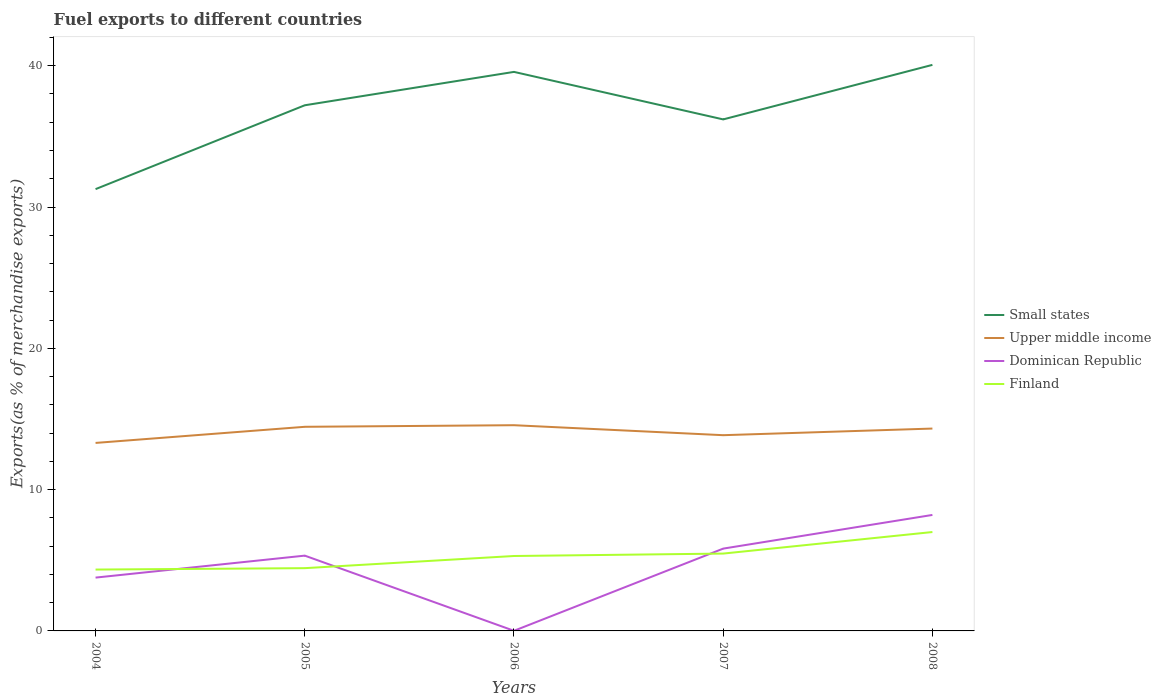Does the line corresponding to Dominican Republic intersect with the line corresponding to Upper middle income?
Your response must be concise. No. Is the number of lines equal to the number of legend labels?
Give a very brief answer. Yes. Across all years, what is the maximum percentage of exports to different countries in Upper middle income?
Keep it short and to the point. 13.31. What is the total percentage of exports to different countries in Upper middle income in the graph?
Keep it short and to the point. -0.11. What is the difference between the highest and the second highest percentage of exports to different countries in Upper middle income?
Make the answer very short. 1.25. How many lines are there?
Your answer should be compact. 4. Does the graph contain any zero values?
Your answer should be compact. No. Where does the legend appear in the graph?
Provide a succinct answer. Center right. How are the legend labels stacked?
Offer a terse response. Vertical. What is the title of the graph?
Provide a short and direct response. Fuel exports to different countries. Does "St. Lucia" appear as one of the legend labels in the graph?
Provide a short and direct response. No. What is the label or title of the Y-axis?
Provide a short and direct response. Exports(as % of merchandise exports). What is the Exports(as % of merchandise exports) of Small states in 2004?
Give a very brief answer. 31.27. What is the Exports(as % of merchandise exports) of Upper middle income in 2004?
Provide a succinct answer. 13.31. What is the Exports(as % of merchandise exports) in Dominican Republic in 2004?
Provide a succinct answer. 3.77. What is the Exports(as % of merchandise exports) in Finland in 2004?
Provide a succinct answer. 4.34. What is the Exports(as % of merchandise exports) in Small states in 2005?
Keep it short and to the point. 37.2. What is the Exports(as % of merchandise exports) of Upper middle income in 2005?
Provide a succinct answer. 14.45. What is the Exports(as % of merchandise exports) of Dominican Republic in 2005?
Ensure brevity in your answer.  5.33. What is the Exports(as % of merchandise exports) in Finland in 2005?
Provide a succinct answer. 4.44. What is the Exports(as % of merchandise exports) in Small states in 2006?
Offer a terse response. 39.56. What is the Exports(as % of merchandise exports) of Upper middle income in 2006?
Provide a short and direct response. 14.56. What is the Exports(as % of merchandise exports) in Dominican Republic in 2006?
Your answer should be compact. 0.01. What is the Exports(as % of merchandise exports) in Finland in 2006?
Give a very brief answer. 5.3. What is the Exports(as % of merchandise exports) in Small states in 2007?
Provide a succinct answer. 36.2. What is the Exports(as % of merchandise exports) of Upper middle income in 2007?
Provide a short and direct response. 13.85. What is the Exports(as % of merchandise exports) in Dominican Republic in 2007?
Provide a succinct answer. 5.83. What is the Exports(as % of merchandise exports) of Finland in 2007?
Offer a terse response. 5.47. What is the Exports(as % of merchandise exports) of Small states in 2008?
Ensure brevity in your answer.  40.06. What is the Exports(as % of merchandise exports) of Upper middle income in 2008?
Provide a short and direct response. 14.32. What is the Exports(as % of merchandise exports) of Dominican Republic in 2008?
Your response must be concise. 8.21. What is the Exports(as % of merchandise exports) in Finland in 2008?
Ensure brevity in your answer.  7. Across all years, what is the maximum Exports(as % of merchandise exports) of Small states?
Provide a succinct answer. 40.06. Across all years, what is the maximum Exports(as % of merchandise exports) of Upper middle income?
Your answer should be compact. 14.56. Across all years, what is the maximum Exports(as % of merchandise exports) in Dominican Republic?
Your response must be concise. 8.21. Across all years, what is the maximum Exports(as % of merchandise exports) of Finland?
Provide a succinct answer. 7. Across all years, what is the minimum Exports(as % of merchandise exports) of Small states?
Keep it short and to the point. 31.27. Across all years, what is the minimum Exports(as % of merchandise exports) in Upper middle income?
Your response must be concise. 13.31. Across all years, what is the minimum Exports(as % of merchandise exports) in Dominican Republic?
Keep it short and to the point. 0.01. Across all years, what is the minimum Exports(as % of merchandise exports) in Finland?
Ensure brevity in your answer.  4.34. What is the total Exports(as % of merchandise exports) in Small states in the graph?
Make the answer very short. 184.29. What is the total Exports(as % of merchandise exports) of Upper middle income in the graph?
Offer a terse response. 70.48. What is the total Exports(as % of merchandise exports) of Dominican Republic in the graph?
Your response must be concise. 23.14. What is the total Exports(as % of merchandise exports) in Finland in the graph?
Provide a short and direct response. 26.56. What is the difference between the Exports(as % of merchandise exports) of Small states in 2004 and that in 2005?
Make the answer very short. -5.93. What is the difference between the Exports(as % of merchandise exports) of Upper middle income in 2004 and that in 2005?
Provide a succinct answer. -1.14. What is the difference between the Exports(as % of merchandise exports) in Dominican Republic in 2004 and that in 2005?
Your answer should be compact. -1.55. What is the difference between the Exports(as % of merchandise exports) in Finland in 2004 and that in 2005?
Offer a very short reply. -0.1. What is the difference between the Exports(as % of merchandise exports) of Small states in 2004 and that in 2006?
Offer a very short reply. -8.3. What is the difference between the Exports(as % of merchandise exports) in Upper middle income in 2004 and that in 2006?
Offer a very short reply. -1.25. What is the difference between the Exports(as % of merchandise exports) of Dominican Republic in 2004 and that in 2006?
Make the answer very short. 3.76. What is the difference between the Exports(as % of merchandise exports) of Finland in 2004 and that in 2006?
Ensure brevity in your answer.  -0.96. What is the difference between the Exports(as % of merchandise exports) in Small states in 2004 and that in 2007?
Keep it short and to the point. -4.93. What is the difference between the Exports(as % of merchandise exports) of Upper middle income in 2004 and that in 2007?
Offer a very short reply. -0.55. What is the difference between the Exports(as % of merchandise exports) of Dominican Republic in 2004 and that in 2007?
Provide a short and direct response. -2.05. What is the difference between the Exports(as % of merchandise exports) of Finland in 2004 and that in 2007?
Provide a short and direct response. -1.13. What is the difference between the Exports(as % of merchandise exports) in Small states in 2004 and that in 2008?
Your response must be concise. -8.79. What is the difference between the Exports(as % of merchandise exports) of Upper middle income in 2004 and that in 2008?
Offer a very short reply. -1.02. What is the difference between the Exports(as % of merchandise exports) in Dominican Republic in 2004 and that in 2008?
Provide a short and direct response. -4.44. What is the difference between the Exports(as % of merchandise exports) of Finland in 2004 and that in 2008?
Your response must be concise. -2.66. What is the difference between the Exports(as % of merchandise exports) of Small states in 2005 and that in 2006?
Provide a succinct answer. -2.36. What is the difference between the Exports(as % of merchandise exports) of Upper middle income in 2005 and that in 2006?
Keep it short and to the point. -0.11. What is the difference between the Exports(as % of merchandise exports) in Dominican Republic in 2005 and that in 2006?
Provide a succinct answer. 5.32. What is the difference between the Exports(as % of merchandise exports) in Finland in 2005 and that in 2006?
Your response must be concise. -0.86. What is the difference between the Exports(as % of merchandise exports) of Small states in 2005 and that in 2007?
Your response must be concise. 1. What is the difference between the Exports(as % of merchandise exports) of Upper middle income in 2005 and that in 2007?
Your response must be concise. 0.59. What is the difference between the Exports(as % of merchandise exports) of Dominican Republic in 2005 and that in 2007?
Offer a very short reply. -0.5. What is the difference between the Exports(as % of merchandise exports) of Finland in 2005 and that in 2007?
Your answer should be very brief. -1.03. What is the difference between the Exports(as % of merchandise exports) of Small states in 2005 and that in 2008?
Provide a succinct answer. -2.86. What is the difference between the Exports(as % of merchandise exports) of Upper middle income in 2005 and that in 2008?
Offer a terse response. 0.12. What is the difference between the Exports(as % of merchandise exports) of Dominican Republic in 2005 and that in 2008?
Your answer should be very brief. -2.88. What is the difference between the Exports(as % of merchandise exports) of Finland in 2005 and that in 2008?
Keep it short and to the point. -2.56. What is the difference between the Exports(as % of merchandise exports) in Small states in 2006 and that in 2007?
Make the answer very short. 3.36. What is the difference between the Exports(as % of merchandise exports) of Upper middle income in 2006 and that in 2007?
Keep it short and to the point. 0.71. What is the difference between the Exports(as % of merchandise exports) of Dominican Republic in 2006 and that in 2007?
Your answer should be compact. -5.82. What is the difference between the Exports(as % of merchandise exports) of Finland in 2006 and that in 2007?
Make the answer very short. -0.17. What is the difference between the Exports(as % of merchandise exports) in Small states in 2006 and that in 2008?
Make the answer very short. -0.5. What is the difference between the Exports(as % of merchandise exports) of Upper middle income in 2006 and that in 2008?
Ensure brevity in your answer.  0.24. What is the difference between the Exports(as % of merchandise exports) in Dominican Republic in 2006 and that in 2008?
Offer a very short reply. -8.2. What is the difference between the Exports(as % of merchandise exports) in Finland in 2006 and that in 2008?
Ensure brevity in your answer.  -1.7. What is the difference between the Exports(as % of merchandise exports) of Small states in 2007 and that in 2008?
Your response must be concise. -3.86. What is the difference between the Exports(as % of merchandise exports) in Upper middle income in 2007 and that in 2008?
Your answer should be compact. -0.47. What is the difference between the Exports(as % of merchandise exports) in Dominican Republic in 2007 and that in 2008?
Keep it short and to the point. -2.38. What is the difference between the Exports(as % of merchandise exports) of Finland in 2007 and that in 2008?
Give a very brief answer. -1.53. What is the difference between the Exports(as % of merchandise exports) in Small states in 2004 and the Exports(as % of merchandise exports) in Upper middle income in 2005?
Your answer should be very brief. 16.82. What is the difference between the Exports(as % of merchandise exports) in Small states in 2004 and the Exports(as % of merchandise exports) in Dominican Republic in 2005?
Keep it short and to the point. 25.94. What is the difference between the Exports(as % of merchandise exports) of Small states in 2004 and the Exports(as % of merchandise exports) of Finland in 2005?
Offer a terse response. 26.82. What is the difference between the Exports(as % of merchandise exports) in Upper middle income in 2004 and the Exports(as % of merchandise exports) in Dominican Republic in 2005?
Give a very brief answer. 7.98. What is the difference between the Exports(as % of merchandise exports) in Upper middle income in 2004 and the Exports(as % of merchandise exports) in Finland in 2005?
Keep it short and to the point. 8.86. What is the difference between the Exports(as % of merchandise exports) in Dominican Republic in 2004 and the Exports(as % of merchandise exports) in Finland in 2005?
Your response must be concise. -0.67. What is the difference between the Exports(as % of merchandise exports) of Small states in 2004 and the Exports(as % of merchandise exports) of Upper middle income in 2006?
Make the answer very short. 16.71. What is the difference between the Exports(as % of merchandise exports) in Small states in 2004 and the Exports(as % of merchandise exports) in Dominican Republic in 2006?
Provide a short and direct response. 31.26. What is the difference between the Exports(as % of merchandise exports) of Small states in 2004 and the Exports(as % of merchandise exports) of Finland in 2006?
Make the answer very short. 25.96. What is the difference between the Exports(as % of merchandise exports) of Upper middle income in 2004 and the Exports(as % of merchandise exports) of Dominican Republic in 2006?
Keep it short and to the point. 13.3. What is the difference between the Exports(as % of merchandise exports) of Upper middle income in 2004 and the Exports(as % of merchandise exports) of Finland in 2006?
Provide a short and direct response. 8. What is the difference between the Exports(as % of merchandise exports) of Dominican Republic in 2004 and the Exports(as % of merchandise exports) of Finland in 2006?
Your answer should be compact. -1.53. What is the difference between the Exports(as % of merchandise exports) of Small states in 2004 and the Exports(as % of merchandise exports) of Upper middle income in 2007?
Make the answer very short. 17.41. What is the difference between the Exports(as % of merchandise exports) of Small states in 2004 and the Exports(as % of merchandise exports) of Dominican Republic in 2007?
Keep it short and to the point. 25.44. What is the difference between the Exports(as % of merchandise exports) of Small states in 2004 and the Exports(as % of merchandise exports) of Finland in 2007?
Offer a very short reply. 25.79. What is the difference between the Exports(as % of merchandise exports) in Upper middle income in 2004 and the Exports(as % of merchandise exports) in Dominican Republic in 2007?
Your response must be concise. 7.48. What is the difference between the Exports(as % of merchandise exports) in Upper middle income in 2004 and the Exports(as % of merchandise exports) in Finland in 2007?
Offer a terse response. 7.83. What is the difference between the Exports(as % of merchandise exports) of Dominican Republic in 2004 and the Exports(as % of merchandise exports) of Finland in 2007?
Provide a short and direct response. -1.7. What is the difference between the Exports(as % of merchandise exports) in Small states in 2004 and the Exports(as % of merchandise exports) in Upper middle income in 2008?
Make the answer very short. 16.94. What is the difference between the Exports(as % of merchandise exports) of Small states in 2004 and the Exports(as % of merchandise exports) of Dominican Republic in 2008?
Provide a succinct answer. 23.06. What is the difference between the Exports(as % of merchandise exports) in Small states in 2004 and the Exports(as % of merchandise exports) in Finland in 2008?
Keep it short and to the point. 24.27. What is the difference between the Exports(as % of merchandise exports) of Upper middle income in 2004 and the Exports(as % of merchandise exports) of Dominican Republic in 2008?
Ensure brevity in your answer.  5.1. What is the difference between the Exports(as % of merchandise exports) in Upper middle income in 2004 and the Exports(as % of merchandise exports) in Finland in 2008?
Your response must be concise. 6.31. What is the difference between the Exports(as % of merchandise exports) in Dominican Republic in 2004 and the Exports(as % of merchandise exports) in Finland in 2008?
Offer a very short reply. -3.23. What is the difference between the Exports(as % of merchandise exports) of Small states in 2005 and the Exports(as % of merchandise exports) of Upper middle income in 2006?
Provide a short and direct response. 22.64. What is the difference between the Exports(as % of merchandise exports) in Small states in 2005 and the Exports(as % of merchandise exports) in Dominican Republic in 2006?
Provide a short and direct response. 37.19. What is the difference between the Exports(as % of merchandise exports) in Small states in 2005 and the Exports(as % of merchandise exports) in Finland in 2006?
Give a very brief answer. 31.9. What is the difference between the Exports(as % of merchandise exports) in Upper middle income in 2005 and the Exports(as % of merchandise exports) in Dominican Republic in 2006?
Ensure brevity in your answer.  14.44. What is the difference between the Exports(as % of merchandise exports) of Upper middle income in 2005 and the Exports(as % of merchandise exports) of Finland in 2006?
Keep it short and to the point. 9.14. What is the difference between the Exports(as % of merchandise exports) in Dominican Republic in 2005 and the Exports(as % of merchandise exports) in Finland in 2006?
Your answer should be compact. 0.03. What is the difference between the Exports(as % of merchandise exports) of Small states in 2005 and the Exports(as % of merchandise exports) of Upper middle income in 2007?
Give a very brief answer. 23.35. What is the difference between the Exports(as % of merchandise exports) in Small states in 2005 and the Exports(as % of merchandise exports) in Dominican Republic in 2007?
Ensure brevity in your answer.  31.38. What is the difference between the Exports(as % of merchandise exports) in Small states in 2005 and the Exports(as % of merchandise exports) in Finland in 2007?
Provide a short and direct response. 31.73. What is the difference between the Exports(as % of merchandise exports) in Upper middle income in 2005 and the Exports(as % of merchandise exports) in Dominican Republic in 2007?
Keep it short and to the point. 8.62. What is the difference between the Exports(as % of merchandise exports) of Upper middle income in 2005 and the Exports(as % of merchandise exports) of Finland in 2007?
Your answer should be compact. 8.97. What is the difference between the Exports(as % of merchandise exports) in Dominican Republic in 2005 and the Exports(as % of merchandise exports) in Finland in 2007?
Offer a very short reply. -0.15. What is the difference between the Exports(as % of merchandise exports) of Small states in 2005 and the Exports(as % of merchandise exports) of Upper middle income in 2008?
Your answer should be compact. 22.88. What is the difference between the Exports(as % of merchandise exports) of Small states in 2005 and the Exports(as % of merchandise exports) of Dominican Republic in 2008?
Give a very brief answer. 28.99. What is the difference between the Exports(as % of merchandise exports) of Small states in 2005 and the Exports(as % of merchandise exports) of Finland in 2008?
Provide a short and direct response. 30.2. What is the difference between the Exports(as % of merchandise exports) in Upper middle income in 2005 and the Exports(as % of merchandise exports) in Dominican Republic in 2008?
Make the answer very short. 6.24. What is the difference between the Exports(as % of merchandise exports) in Upper middle income in 2005 and the Exports(as % of merchandise exports) in Finland in 2008?
Provide a short and direct response. 7.45. What is the difference between the Exports(as % of merchandise exports) in Dominican Republic in 2005 and the Exports(as % of merchandise exports) in Finland in 2008?
Make the answer very short. -1.67. What is the difference between the Exports(as % of merchandise exports) of Small states in 2006 and the Exports(as % of merchandise exports) of Upper middle income in 2007?
Offer a very short reply. 25.71. What is the difference between the Exports(as % of merchandise exports) of Small states in 2006 and the Exports(as % of merchandise exports) of Dominican Republic in 2007?
Offer a very short reply. 33.74. What is the difference between the Exports(as % of merchandise exports) in Small states in 2006 and the Exports(as % of merchandise exports) in Finland in 2007?
Make the answer very short. 34.09. What is the difference between the Exports(as % of merchandise exports) of Upper middle income in 2006 and the Exports(as % of merchandise exports) of Dominican Republic in 2007?
Your answer should be compact. 8.73. What is the difference between the Exports(as % of merchandise exports) in Upper middle income in 2006 and the Exports(as % of merchandise exports) in Finland in 2007?
Ensure brevity in your answer.  9.09. What is the difference between the Exports(as % of merchandise exports) of Dominican Republic in 2006 and the Exports(as % of merchandise exports) of Finland in 2007?
Ensure brevity in your answer.  -5.46. What is the difference between the Exports(as % of merchandise exports) in Small states in 2006 and the Exports(as % of merchandise exports) in Upper middle income in 2008?
Offer a terse response. 25.24. What is the difference between the Exports(as % of merchandise exports) in Small states in 2006 and the Exports(as % of merchandise exports) in Dominican Republic in 2008?
Provide a succinct answer. 31.36. What is the difference between the Exports(as % of merchandise exports) in Small states in 2006 and the Exports(as % of merchandise exports) in Finland in 2008?
Make the answer very short. 32.56. What is the difference between the Exports(as % of merchandise exports) of Upper middle income in 2006 and the Exports(as % of merchandise exports) of Dominican Republic in 2008?
Give a very brief answer. 6.35. What is the difference between the Exports(as % of merchandise exports) of Upper middle income in 2006 and the Exports(as % of merchandise exports) of Finland in 2008?
Your response must be concise. 7.56. What is the difference between the Exports(as % of merchandise exports) in Dominican Republic in 2006 and the Exports(as % of merchandise exports) in Finland in 2008?
Offer a very short reply. -6.99. What is the difference between the Exports(as % of merchandise exports) of Small states in 2007 and the Exports(as % of merchandise exports) of Upper middle income in 2008?
Your answer should be compact. 21.88. What is the difference between the Exports(as % of merchandise exports) in Small states in 2007 and the Exports(as % of merchandise exports) in Dominican Republic in 2008?
Keep it short and to the point. 27.99. What is the difference between the Exports(as % of merchandise exports) of Small states in 2007 and the Exports(as % of merchandise exports) of Finland in 2008?
Provide a short and direct response. 29.2. What is the difference between the Exports(as % of merchandise exports) of Upper middle income in 2007 and the Exports(as % of merchandise exports) of Dominican Republic in 2008?
Make the answer very short. 5.64. What is the difference between the Exports(as % of merchandise exports) in Upper middle income in 2007 and the Exports(as % of merchandise exports) in Finland in 2008?
Give a very brief answer. 6.85. What is the difference between the Exports(as % of merchandise exports) of Dominican Republic in 2007 and the Exports(as % of merchandise exports) of Finland in 2008?
Provide a succinct answer. -1.17. What is the average Exports(as % of merchandise exports) in Small states per year?
Offer a very short reply. 36.86. What is the average Exports(as % of merchandise exports) of Upper middle income per year?
Your answer should be compact. 14.1. What is the average Exports(as % of merchandise exports) in Dominican Republic per year?
Ensure brevity in your answer.  4.63. What is the average Exports(as % of merchandise exports) of Finland per year?
Make the answer very short. 5.31. In the year 2004, what is the difference between the Exports(as % of merchandise exports) of Small states and Exports(as % of merchandise exports) of Upper middle income?
Keep it short and to the point. 17.96. In the year 2004, what is the difference between the Exports(as % of merchandise exports) in Small states and Exports(as % of merchandise exports) in Dominican Republic?
Offer a very short reply. 27.49. In the year 2004, what is the difference between the Exports(as % of merchandise exports) of Small states and Exports(as % of merchandise exports) of Finland?
Keep it short and to the point. 26.92. In the year 2004, what is the difference between the Exports(as % of merchandise exports) of Upper middle income and Exports(as % of merchandise exports) of Dominican Republic?
Keep it short and to the point. 9.53. In the year 2004, what is the difference between the Exports(as % of merchandise exports) in Upper middle income and Exports(as % of merchandise exports) in Finland?
Provide a succinct answer. 8.96. In the year 2004, what is the difference between the Exports(as % of merchandise exports) of Dominican Republic and Exports(as % of merchandise exports) of Finland?
Give a very brief answer. -0.57. In the year 2005, what is the difference between the Exports(as % of merchandise exports) of Small states and Exports(as % of merchandise exports) of Upper middle income?
Your response must be concise. 22.76. In the year 2005, what is the difference between the Exports(as % of merchandise exports) of Small states and Exports(as % of merchandise exports) of Dominican Republic?
Keep it short and to the point. 31.87. In the year 2005, what is the difference between the Exports(as % of merchandise exports) of Small states and Exports(as % of merchandise exports) of Finland?
Ensure brevity in your answer.  32.76. In the year 2005, what is the difference between the Exports(as % of merchandise exports) of Upper middle income and Exports(as % of merchandise exports) of Dominican Republic?
Offer a terse response. 9.12. In the year 2005, what is the difference between the Exports(as % of merchandise exports) of Upper middle income and Exports(as % of merchandise exports) of Finland?
Keep it short and to the point. 10. In the year 2005, what is the difference between the Exports(as % of merchandise exports) of Dominican Republic and Exports(as % of merchandise exports) of Finland?
Make the answer very short. 0.89. In the year 2006, what is the difference between the Exports(as % of merchandise exports) of Small states and Exports(as % of merchandise exports) of Upper middle income?
Ensure brevity in your answer.  25.01. In the year 2006, what is the difference between the Exports(as % of merchandise exports) in Small states and Exports(as % of merchandise exports) in Dominican Republic?
Ensure brevity in your answer.  39.55. In the year 2006, what is the difference between the Exports(as % of merchandise exports) in Small states and Exports(as % of merchandise exports) in Finland?
Keep it short and to the point. 34.26. In the year 2006, what is the difference between the Exports(as % of merchandise exports) of Upper middle income and Exports(as % of merchandise exports) of Dominican Republic?
Keep it short and to the point. 14.55. In the year 2006, what is the difference between the Exports(as % of merchandise exports) of Upper middle income and Exports(as % of merchandise exports) of Finland?
Make the answer very short. 9.26. In the year 2006, what is the difference between the Exports(as % of merchandise exports) of Dominican Republic and Exports(as % of merchandise exports) of Finland?
Your answer should be compact. -5.29. In the year 2007, what is the difference between the Exports(as % of merchandise exports) of Small states and Exports(as % of merchandise exports) of Upper middle income?
Offer a very short reply. 22.35. In the year 2007, what is the difference between the Exports(as % of merchandise exports) in Small states and Exports(as % of merchandise exports) in Dominican Republic?
Offer a terse response. 30.38. In the year 2007, what is the difference between the Exports(as % of merchandise exports) of Small states and Exports(as % of merchandise exports) of Finland?
Your answer should be compact. 30.73. In the year 2007, what is the difference between the Exports(as % of merchandise exports) of Upper middle income and Exports(as % of merchandise exports) of Dominican Republic?
Ensure brevity in your answer.  8.03. In the year 2007, what is the difference between the Exports(as % of merchandise exports) in Upper middle income and Exports(as % of merchandise exports) in Finland?
Provide a succinct answer. 8.38. In the year 2007, what is the difference between the Exports(as % of merchandise exports) of Dominican Republic and Exports(as % of merchandise exports) of Finland?
Your answer should be compact. 0.35. In the year 2008, what is the difference between the Exports(as % of merchandise exports) of Small states and Exports(as % of merchandise exports) of Upper middle income?
Make the answer very short. 25.74. In the year 2008, what is the difference between the Exports(as % of merchandise exports) in Small states and Exports(as % of merchandise exports) in Dominican Republic?
Provide a succinct answer. 31.85. In the year 2008, what is the difference between the Exports(as % of merchandise exports) in Small states and Exports(as % of merchandise exports) in Finland?
Offer a very short reply. 33.06. In the year 2008, what is the difference between the Exports(as % of merchandise exports) in Upper middle income and Exports(as % of merchandise exports) in Dominican Republic?
Provide a short and direct response. 6.11. In the year 2008, what is the difference between the Exports(as % of merchandise exports) of Upper middle income and Exports(as % of merchandise exports) of Finland?
Give a very brief answer. 7.32. In the year 2008, what is the difference between the Exports(as % of merchandise exports) in Dominican Republic and Exports(as % of merchandise exports) in Finland?
Offer a very short reply. 1.21. What is the ratio of the Exports(as % of merchandise exports) of Small states in 2004 to that in 2005?
Offer a very short reply. 0.84. What is the ratio of the Exports(as % of merchandise exports) of Upper middle income in 2004 to that in 2005?
Provide a short and direct response. 0.92. What is the ratio of the Exports(as % of merchandise exports) in Dominican Republic in 2004 to that in 2005?
Make the answer very short. 0.71. What is the ratio of the Exports(as % of merchandise exports) in Finland in 2004 to that in 2005?
Your response must be concise. 0.98. What is the ratio of the Exports(as % of merchandise exports) of Small states in 2004 to that in 2006?
Make the answer very short. 0.79. What is the ratio of the Exports(as % of merchandise exports) of Upper middle income in 2004 to that in 2006?
Give a very brief answer. 0.91. What is the ratio of the Exports(as % of merchandise exports) of Dominican Republic in 2004 to that in 2006?
Give a very brief answer. 403.69. What is the ratio of the Exports(as % of merchandise exports) of Finland in 2004 to that in 2006?
Give a very brief answer. 0.82. What is the ratio of the Exports(as % of merchandise exports) in Small states in 2004 to that in 2007?
Offer a terse response. 0.86. What is the ratio of the Exports(as % of merchandise exports) in Upper middle income in 2004 to that in 2007?
Offer a very short reply. 0.96. What is the ratio of the Exports(as % of merchandise exports) of Dominican Republic in 2004 to that in 2007?
Your answer should be compact. 0.65. What is the ratio of the Exports(as % of merchandise exports) in Finland in 2004 to that in 2007?
Your answer should be very brief. 0.79. What is the ratio of the Exports(as % of merchandise exports) in Small states in 2004 to that in 2008?
Provide a succinct answer. 0.78. What is the ratio of the Exports(as % of merchandise exports) of Upper middle income in 2004 to that in 2008?
Provide a short and direct response. 0.93. What is the ratio of the Exports(as % of merchandise exports) of Dominican Republic in 2004 to that in 2008?
Keep it short and to the point. 0.46. What is the ratio of the Exports(as % of merchandise exports) of Finland in 2004 to that in 2008?
Give a very brief answer. 0.62. What is the ratio of the Exports(as % of merchandise exports) in Small states in 2005 to that in 2006?
Offer a terse response. 0.94. What is the ratio of the Exports(as % of merchandise exports) of Upper middle income in 2005 to that in 2006?
Give a very brief answer. 0.99. What is the ratio of the Exports(as % of merchandise exports) in Dominican Republic in 2005 to that in 2006?
Make the answer very short. 570.02. What is the ratio of the Exports(as % of merchandise exports) of Finland in 2005 to that in 2006?
Ensure brevity in your answer.  0.84. What is the ratio of the Exports(as % of merchandise exports) of Small states in 2005 to that in 2007?
Make the answer very short. 1.03. What is the ratio of the Exports(as % of merchandise exports) in Upper middle income in 2005 to that in 2007?
Keep it short and to the point. 1.04. What is the ratio of the Exports(as % of merchandise exports) of Dominican Republic in 2005 to that in 2007?
Your response must be concise. 0.91. What is the ratio of the Exports(as % of merchandise exports) in Finland in 2005 to that in 2007?
Provide a short and direct response. 0.81. What is the ratio of the Exports(as % of merchandise exports) of Small states in 2005 to that in 2008?
Keep it short and to the point. 0.93. What is the ratio of the Exports(as % of merchandise exports) of Upper middle income in 2005 to that in 2008?
Ensure brevity in your answer.  1.01. What is the ratio of the Exports(as % of merchandise exports) of Dominican Republic in 2005 to that in 2008?
Keep it short and to the point. 0.65. What is the ratio of the Exports(as % of merchandise exports) of Finland in 2005 to that in 2008?
Provide a succinct answer. 0.63. What is the ratio of the Exports(as % of merchandise exports) in Small states in 2006 to that in 2007?
Ensure brevity in your answer.  1.09. What is the ratio of the Exports(as % of merchandise exports) of Upper middle income in 2006 to that in 2007?
Make the answer very short. 1.05. What is the ratio of the Exports(as % of merchandise exports) of Dominican Republic in 2006 to that in 2007?
Your answer should be very brief. 0. What is the ratio of the Exports(as % of merchandise exports) of Finland in 2006 to that in 2007?
Provide a short and direct response. 0.97. What is the ratio of the Exports(as % of merchandise exports) of Small states in 2006 to that in 2008?
Ensure brevity in your answer.  0.99. What is the ratio of the Exports(as % of merchandise exports) in Upper middle income in 2006 to that in 2008?
Offer a terse response. 1.02. What is the ratio of the Exports(as % of merchandise exports) in Dominican Republic in 2006 to that in 2008?
Your response must be concise. 0. What is the ratio of the Exports(as % of merchandise exports) in Finland in 2006 to that in 2008?
Give a very brief answer. 0.76. What is the ratio of the Exports(as % of merchandise exports) of Small states in 2007 to that in 2008?
Your answer should be very brief. 0.9. What is the ratio of the Exports(as % of merchandise exports) of Upper middle income in 2007 to that in 2008?
Your answer should be very brief. 0.97. What is the ratio of the Exports(as % of merchandise exports) of Dominican Republic in 2007 to that in 2008?
Your answer should be compact. 0.71. What is the ratio of the Exports(as % of merchandise exports) of Finland in 2007 to that in 2008?
Provide a short and direct response. 0.78. What is the difference between the highest and the second highest Exports(as % of merchandise exports) of Small states?
Give a very brief answer. 0.5. What is the difference between the highest and the second highest Exports(as % of merchandise exports) in Upper middle income?
Your response must be concise. 0.11. What is the difference between the highest and the second highest Exports(as % of merchandise exports) of Dominican Republic?
Offer a very short reply. 2.38. What is the difference between the highest and the second highest Exports(as % of merchandise exports) of Finland?
Your response must be concise. 1.53. What is the difference between the highest and the lowest Exports(as % of merchandise exports) in Small states?
Make the answer very short. 8.79. What is the difference between the highest and the lowest Exports(as % of merchandise exports) of Upper middle income?
Keep it short and to the point. 1.25. What is the difference between the highest and the lowest Exports(as % of merchandise exports) in Dominican Republic?
Your answer should be compact. 8.2. What is the difference between the highest and the lowest Exports(as % of merchandise exports) in Finland?
Provide a short and direct response. 2.66. 